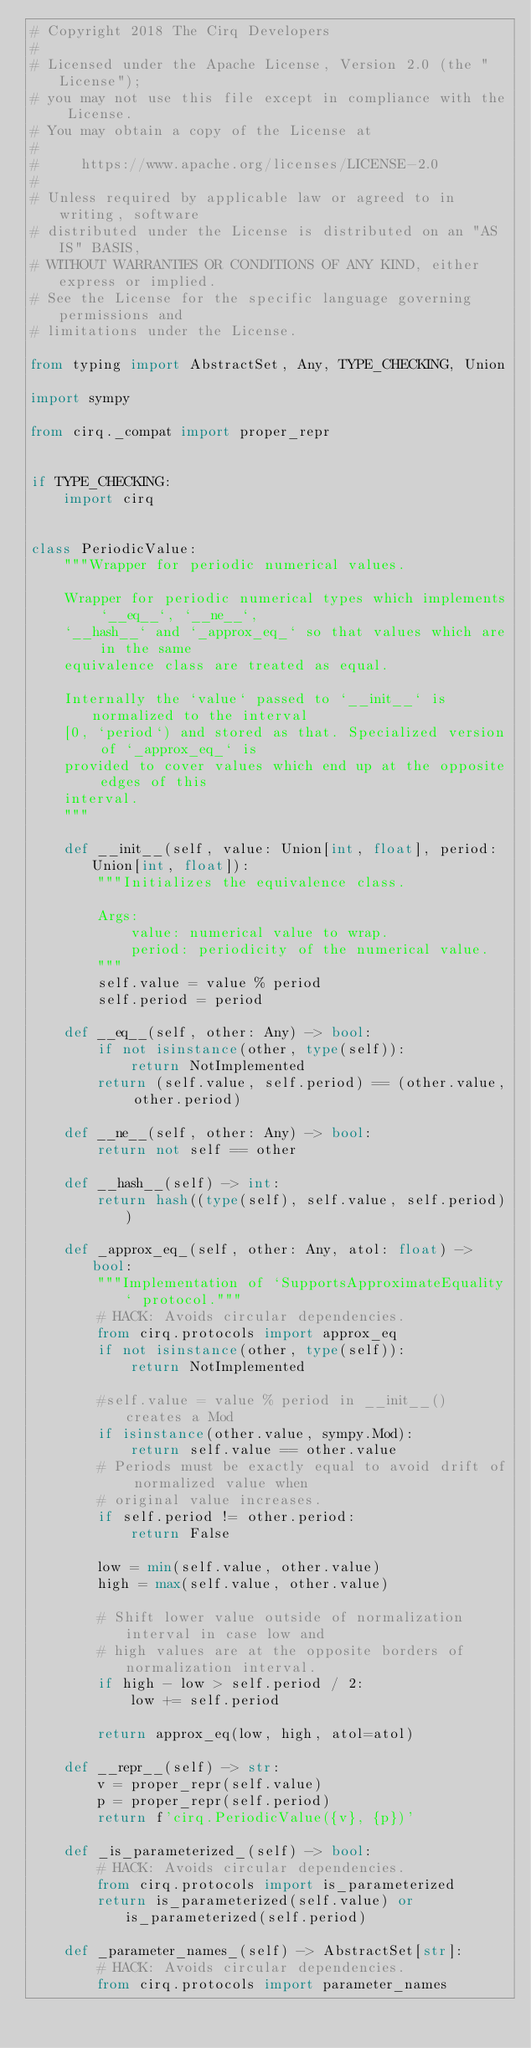<code> <loc_0><loc_0><loc_500><loc_500><_Python_># Copyright 2018 The Cirq Developers
#
# Licensed under the Apache License, Version 2.0 (the "License");
# you may not use this file except in compliance with the License.
# You may obtain a copy of the License at
#
#     https://www.apache.org/licenses/LICENSE-2.0
#
# Unless required by applicable law or agreed to in writing, software
# distributed under the License is distributed on an "AS IS" BASIS,
# WITHOUT WARRANTIES OR CONDITIONS OF ANY KIND, either express or implied.
# See the License for the specific language governing permissions and
# limitations under the License.

from typing import AbstractSet, Any, TYPE_CHECKING, Union

import sympy

from cirq._compat import proper_repr


if TYPE_CHECKING:
    import cirq


class PeriodicValue:
    """Wrapper for periodic numerical values.

    Wrapper for periodic numerical types which implements `__eq__`, `__ne__`,
    `__hash__` and `_approx_eq_` so that values which are in the same
    equivalence class are treated as equal.

    Internally the `value` passed to `__init__` is normalized to the interval
    [0, `period`) and stored as that. Specialized version of `_approx_eq_` is
    provided to cover values which end up at the opposite edges of this
    interval.
    """

    def __init__(self, value: Union[int, float], period: Union[int, float]):
        """Initializes the equivalence class.

        Args:
            value: numerical value to wrap.
            period: periodicity of the numerical value.
        """
        self.value = value % period
        self.period = period

    def __eq__(self, other: Any) -> bool:
        if not isinstance(other, type(self)):
            return NotImplemented
        return (self.value, self.period) == (other.value, other.period)

    def __ne__(self, other: Any) -> bool:
        return not self == other

    def __hash__(self) -> int:
        return hash((type(self), self.value, self.period))

    def _approx_eq_(self, other: Any, atol: float) -> bool:
        """Implementation of `SupportsApproximateEquality` protocol."""
        # HACK: Avoids circular dependencies.
        from cirq.protocols import approx_eq
        if not isinstance(other, type(self)):
            return NotImplemented

        #self.value = value % period in __init__() creates a Mod
        if isinstance(other.value, sympy.Mod):
            return self.value == other.value
        # Periods must be exactly equal to avoid drift of normalized value when
        # original value increases.
        if self.period != other.period:
            return False

        low = min(self.value, other.value)
        high = max(self.value, other.value)

        # Shift lower value outside of normalization interval in case low and
        # high values are at the opposite borders of normalization interval.
        if high - low > self.period / 2:
            low += self.period

        return approx_eq(low, high, atol=atol)

    def __repr__(self) -> str:
        v = proper_repr(self.value)
        p = proper_repr(self.period)
        return f'cirq.PeriodicValue({v}, {p})'

    def _is_parameterized_(self) -> bool:
        # HACK: Avoids circular dependencies.
        from cirq.protocols import is_parameterized
        return is_parameterized(self.value) or is_parameterized(self.period)

    def _parameter_names_(self) -> AbstractSet[str]:
        # HACK: Avoids circular dependencies.
        from cirq.protocols import parameter_names</code> 